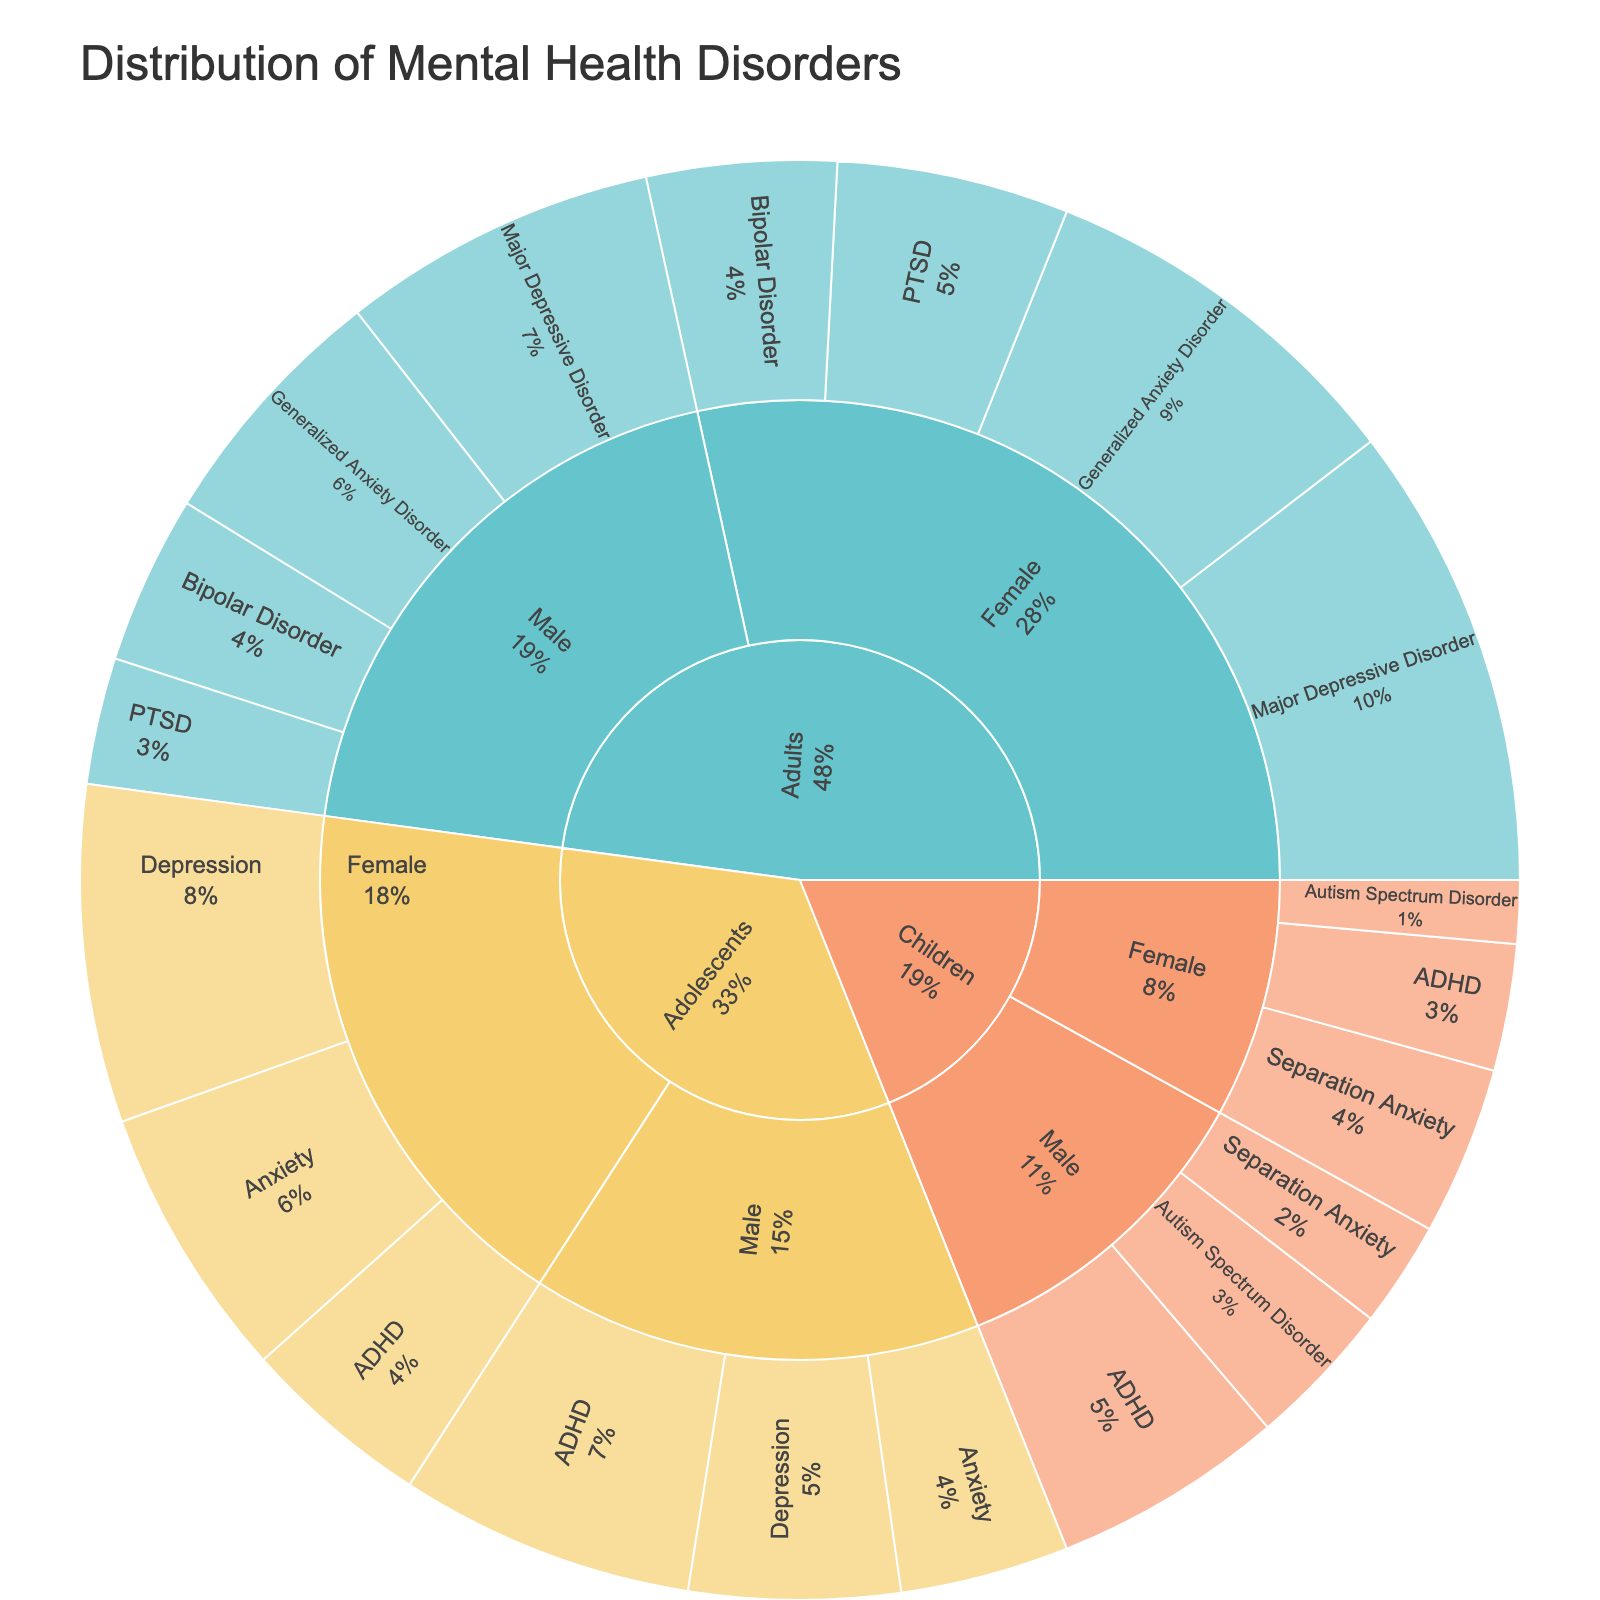What is the title of the figure? The title of the figure is prominently displayed at the top of the plot.
Answer: Distribution of Mental Health Disorders Which category has the highest value for Major Depressive Disorder? Looking at the segments of the sunburst plot labeled "Major Depressive Disorder" for various subcategories and comparing the values, Adults and Female has the highest value.
Answer: Adults, Female What is the total value for ADHD across all categories? To get the total, sum the values for ADHD in all subcategories: 14 (Adolescents, Male) + 9 (Adolescents, Female) + 11 (Children, Male) + 6 (Children, Female).
Answer: 40 Which gender in the Adults category has a higher incidence of Bipolar Disorder? Comparing the values for Bipolar Disorder in Adults, Male (8) and Female (9), Female has a higher value (9).
Answer: Female How does the value of PTSD in Adult Males compare with Adult Females? The values for PTSD in Adult Males and Females are 6 and 11, respectively. Adult Females have a higher value.
Answer: Adult Females Which diagnosis has the lowest value amongst Children? By reviewing the segments under the Children category, Autism Spectrum Disorder in Females has the lowest value of 3.
Answer: Autism Spectrum Disorder, Females What is the sum of Generalized Anxiety Disorder cases in Adults? Adding up the values for Generalized Anxiety Disorder in Male (12) and Female (18) categories within Adults: 12 + 18.
Answer: 30 Which specific diagnosis in Adolescents is most common? Among the diagnoses in the Adolescents category, Depression in Females has the highest value (16).
Answer: Depression, Females What percentage of all Major Depressive Disorder cases are found in Females (both Adults and Adolescents)? Summing the values for Major Depressive Disorder in Adult Females (22) and Adolescents Females (16) and dividing it by the total value in these two subcategories, then multiplying by 100: (22 + 16)/(22 + 16 + 15 + 10) * 100.
Answer: 72% In which category is Separation Anxiety observed, and which gender has a higher incidence? Separation Anxiety is observed in the Children category. Comparing the values for Male (5) and Female (8), Female has a higher incidence.
Answer: Children, Female 